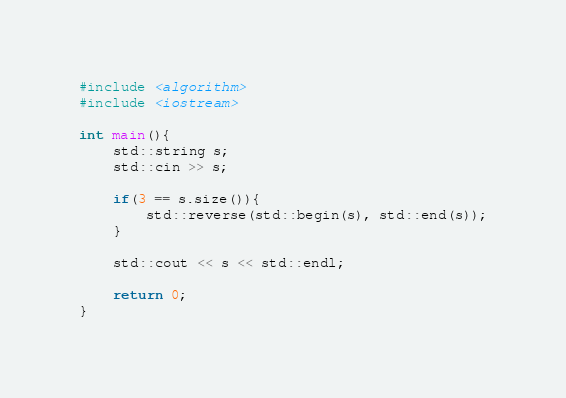Convert code to text. <code><loc_0><loc_0><loc_500><loc_500><_C++_>#include <algorithm>
#include <iostream>

int main(){
    std::string s;
    std::cin >> s;

    if(3 == s.size()){
        std::reverse(std::begin(s), std::end(s));
    }

    std::cout << s << std::endl;

    return 0;
}</code> 